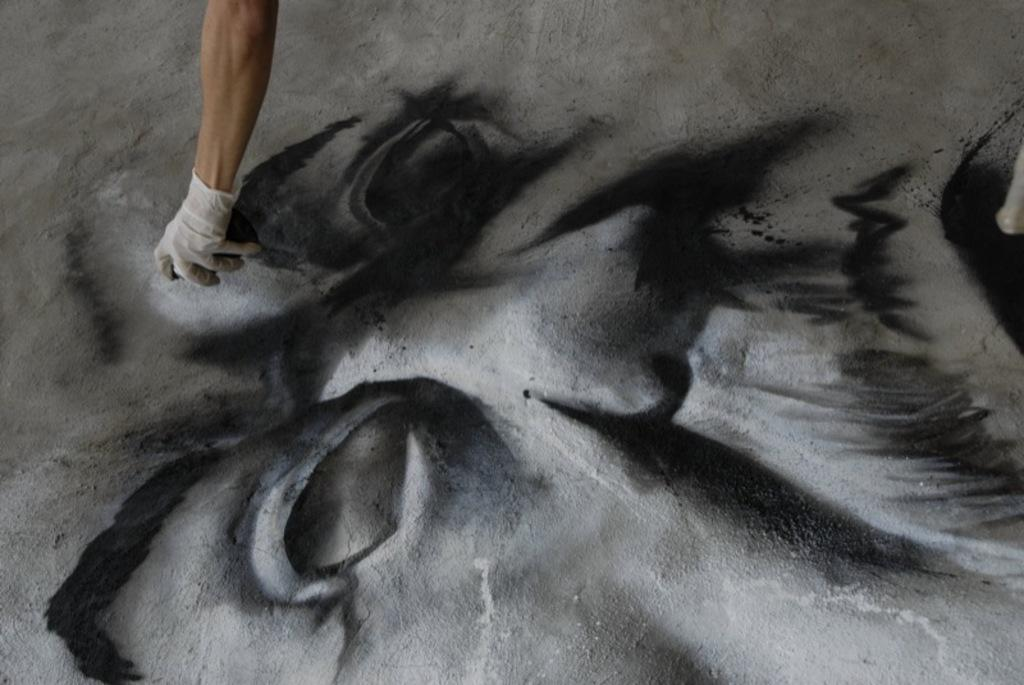What is the main subject of the image? There is a person in the image. What is the person doing in the image? The person is painting. What type of sweater is the person wearing while painting in the image? There is no mention of a sweater or any clothing in the image; the person is simply painting. 